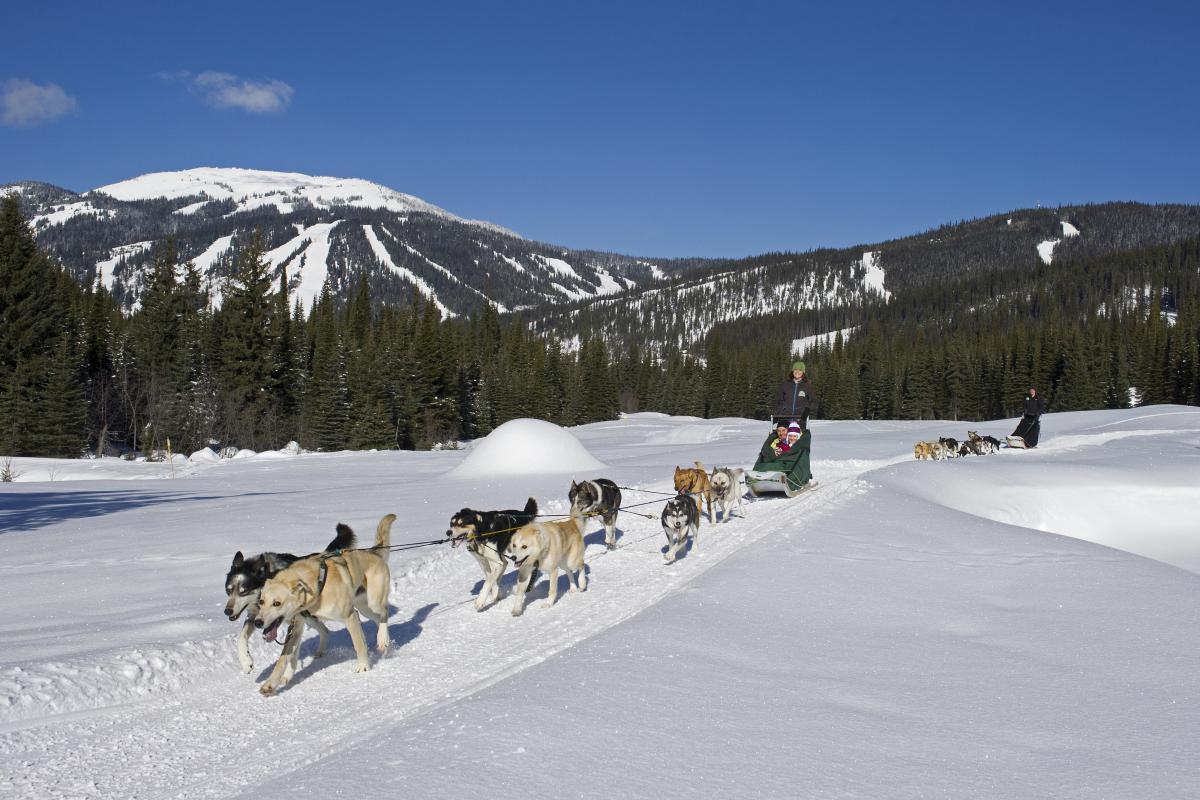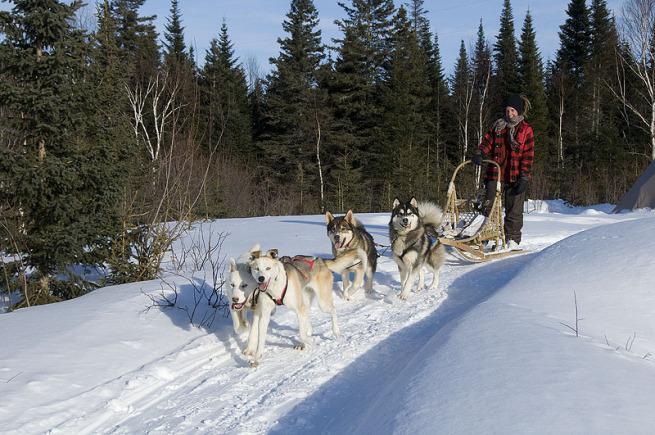The first image is the image on the left, the second image is the image on the right. Assess this claim about the two images: "A sled driver in red and black leads a team of dogs diagonally to the left past stands of evergreen trees.". Correct or not? Answer yes or no. Yes. The first image is the image on the left, the second image is the image on the right. Evaluate the accuracy of this statement regarding the images: "All the sled dogs in the left image are running towards the left.". Is it true? Answer yes or no. Yes. 